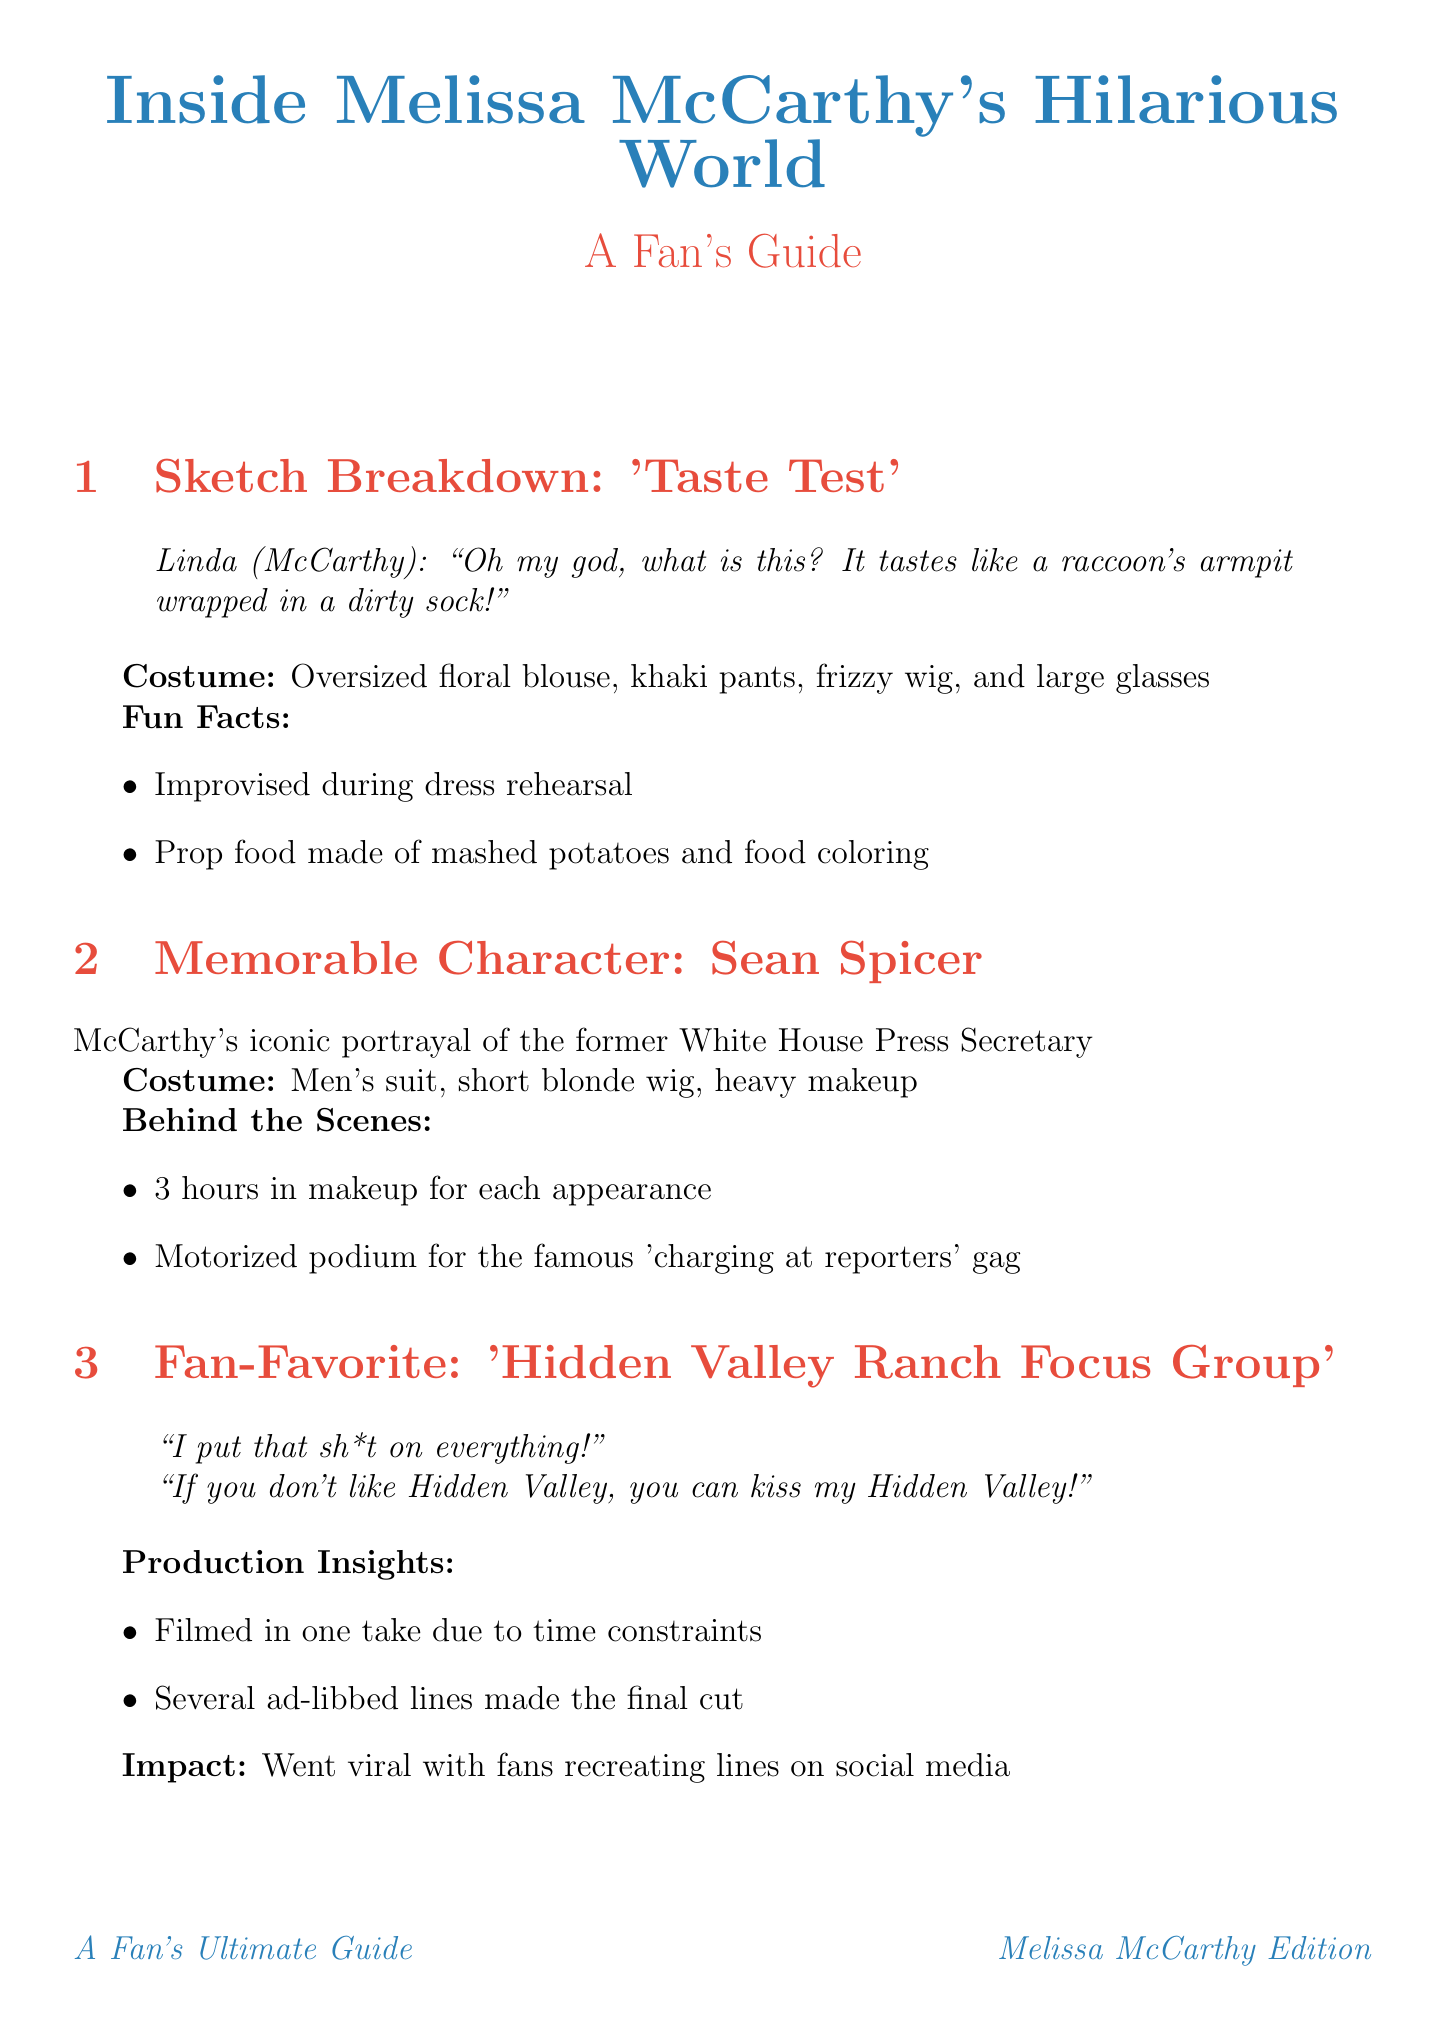What is the title of the newsletter? The title of the newsletter is stated at the beginning, providing insight into its content focus.
Answer: Inside Melissa McCarthy's Hilarious World: A Fan's Guide What character is featured in the "Hidden Valley Ranch Focus Group" sketch? This question relates to identifying the specific sketch mentioned in the newsletter and its main character.
Answer: Not specified What costume did McCarthy wear for the "Taste Test" sketch? Understanding the specific costume details helps to visualize the character McCarthy portrayed.
Answer: Oversized floral blouse, khaki pants, frizzy wig, and large glasses How many hours did McCarthy spend in makeup for the Sean Spicer character? This detail highlights the effort put into the character's appearance emphasizing her commitment to authenticity.
Answer: 3 hours What was the viewer's reaction to the "Falling Down the Stairs" sketch? This question focuses on audience engagement, reflecting the impact of the performance.
Answer: Standing ovation What type of comedy is showcased in the "Falling Down the Stairs"? This question aims to identify the style of comedy presented in that specific sketch.
Answer: Physical comedy What was the filming constraint for the "Hidden Valley Ranch Focus Group" sketch? This question addresses the production challenges that influenced how the sketch was created.
Answer: Filmed in one take Which character evolved from a simple soccer mom outfit to a bedazzled tracksuit? This question sources character transformation details, illustrating development over time within sketches.
Answer: Sheila Kelly 